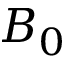Convert formula to latex. <formula><loc_0><loc_0><loc_500><loc_500>B _ { 0 }</formula> 